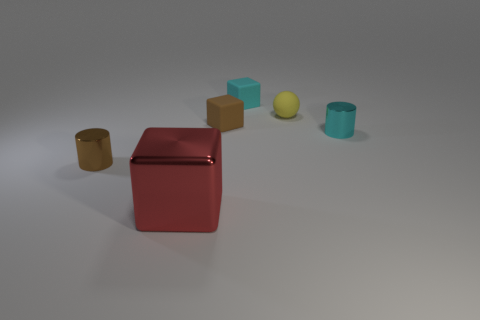Subtract all matte cubes. How many cubes are left? 1 Add 3 small brown cylinders. How many objects exist? 9 Subtract all cylinders. How many objects are left? 4 Add 3 gray rubber spheres. How many gray rubber spheres exist? 3 Subtract 0 green balls. How many objects are left? 6 Subtract all blocks. Subtract all small cyan things. How many objects are left? 1 Add 5 big objects. How many big objects are left? 6 